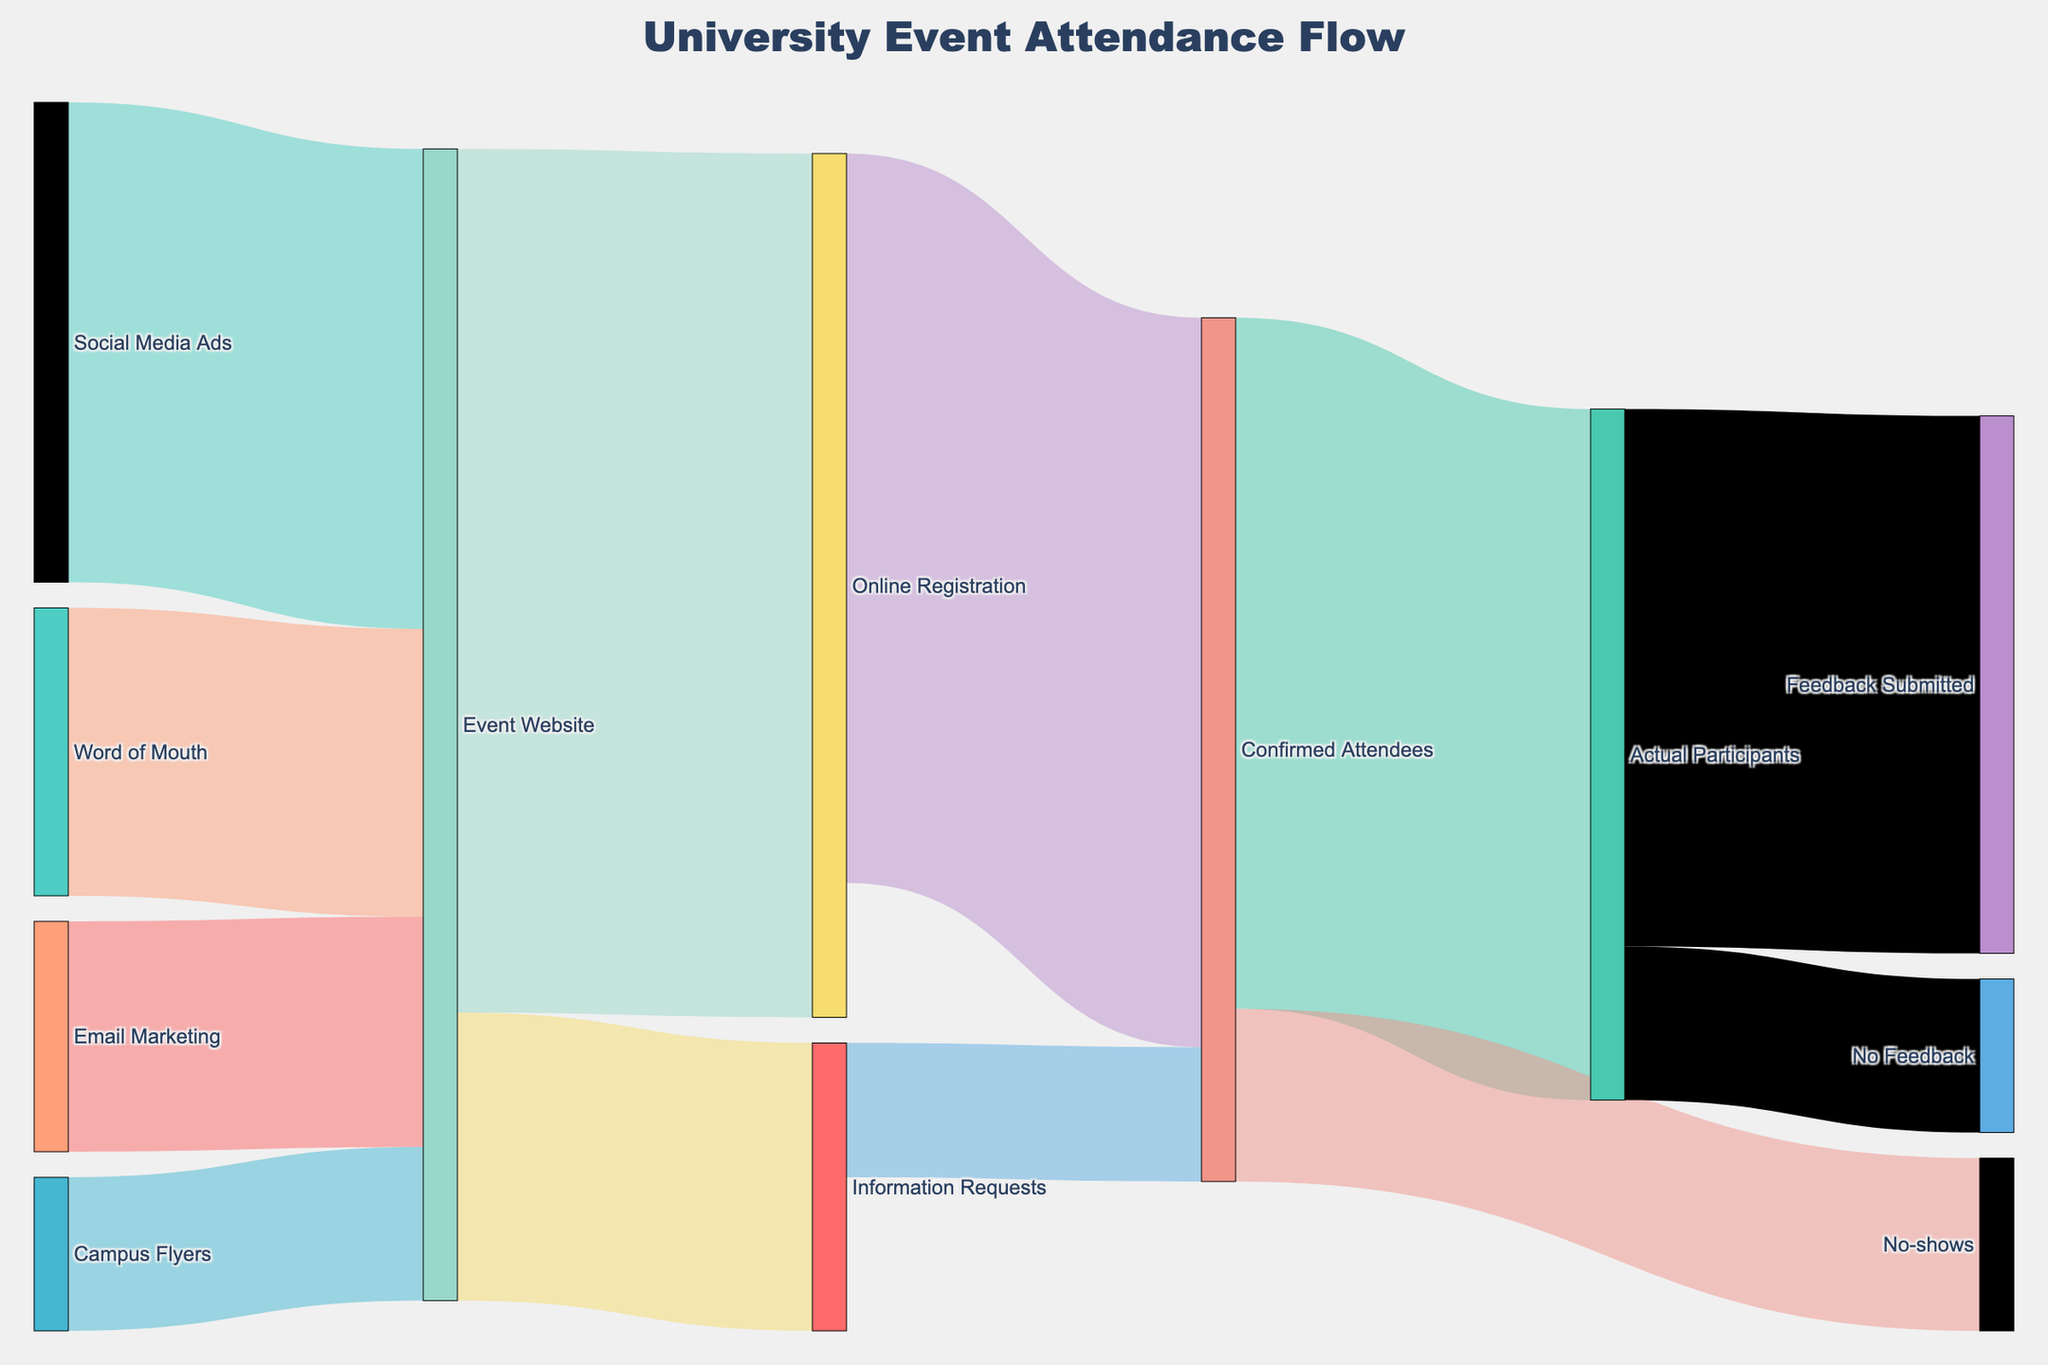What's the title of the Sankey Diagram? The title is displayed at the top of the diagram, describing the subject matter it visualizes.
Answer: University Event Attendance Flow Which marketing channel contributed the most to the Event Website? By comparing the values associated with each marketing channel leading to the Event Website, the highest value indicates the greatest contribution. Social Media Ads contributed 2500, which is the highest value compared to other channels.
Answer: Social Media Ads How many people originally visited the Event Website? Sum the incoming values to the Event Website: 1200 (Email Marketing) + 2500 (Social Media Ads) + 800 (Campus Flyers) + 1500 (Word of Mouth) = 6000.
Answer: 6000 What percentage of confirmed attendees were actual participants? To find the percentage, divide the number of actual participants by the number of confirmed attendees and multiply by 100: (3600 / 4500) * 100 = 80%.
Answer: 80% How many attendees did not submit feedback after participating in the event? The value moving from Actual Participants to No Feedback is given directly in the figure.
Answer: 800 What is the difference between those who registered online and those who requested information? Subtract the number of Information Requests from the number of Online Registrations: 4500 - 1500 = 3000.
Answer: 3000 How many confirmed attendees didn't show up for the event? The value moving from Confirmed Attendees to No-shows is provided in the diagram.
Answer: 900 Which outcome had the fewest people, submitting feedback or not submitting feedback? Compare the values for Feedback Submitted (2800) and No Feedback (800). No Feedback has the fewer people.
Answer: No Feedback What is the total number of confirmed attendees? Sum the values for Actual Participants and No-shows: 3600 + 900 = 4500.
Answer: 4500 